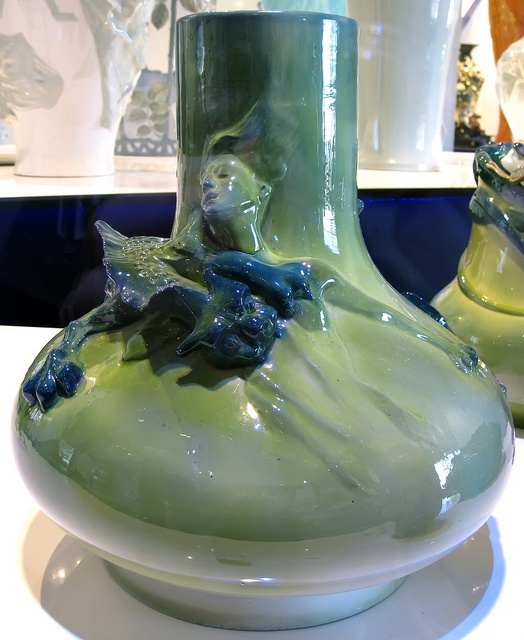Describe the objects in this image and their specific colors. I can see vase in darkgray, gray, and black tones and vase in darkgray, olive, gray, and black tones in this image. 